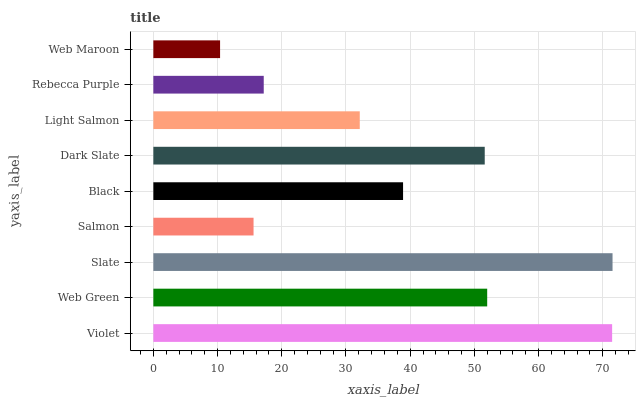Is Web Maroon the minimum?
Answer yes or no. Yes. Is Slate the maximum?
Answer yes or no. Yes. Is Web Green the minimum?
Answer yes or no. No. Is Web Green the maximum?
Answer yes or no. No. Is Violet greater than Web Green?
Answer yes or no. Yes. Is Web Green less than Violet?
Answer yes or no. Yes. Is Web Green greater than Violet?
Answer yes or no. No. Is Violet less than Web Green?
Answer yes or no. No. Is Black the high median?
Answer yes or no. Yes. Is Black the low median?
Answer yes or no. Yes. Is Rebecca Purple the high median?
Answer yes or no. No. Is Dark Slate the low median?
Answer yes or no. No. 